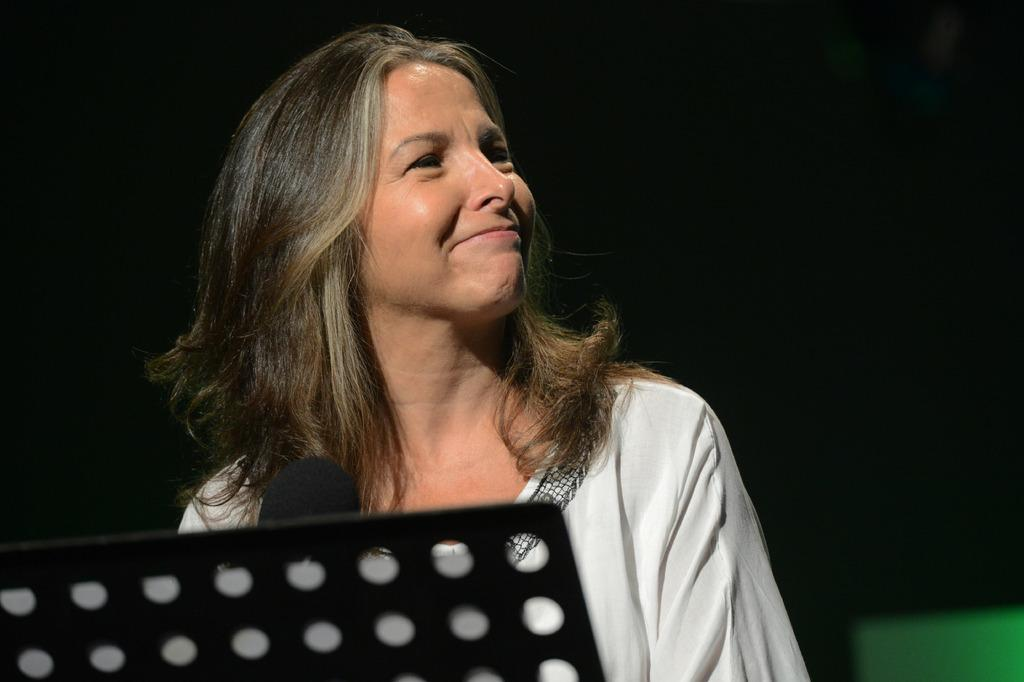Who is the main subject in the image? There is a woman in the image. What is the woman doing in the image? The woman is in front of a mic, which suggests she might be speaking or singing. What object is in front of the woman? There is a metal object in front of the woman. What can be observed about the background of the image? The background of the image is dark. Can you see a wren perched on the metal object in the image? There is no wren present in the image. What type of ornament is hanging from the mic in the image? There is no ornament hanging from the mic in the image. 